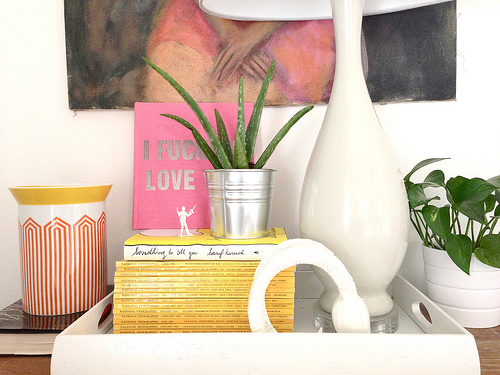<image>
Can you confirm if the books is behind the lamp? No. The books is not behind the lamp. From this viewpoint, the books appears to be positioned elsewhere in the scene. 